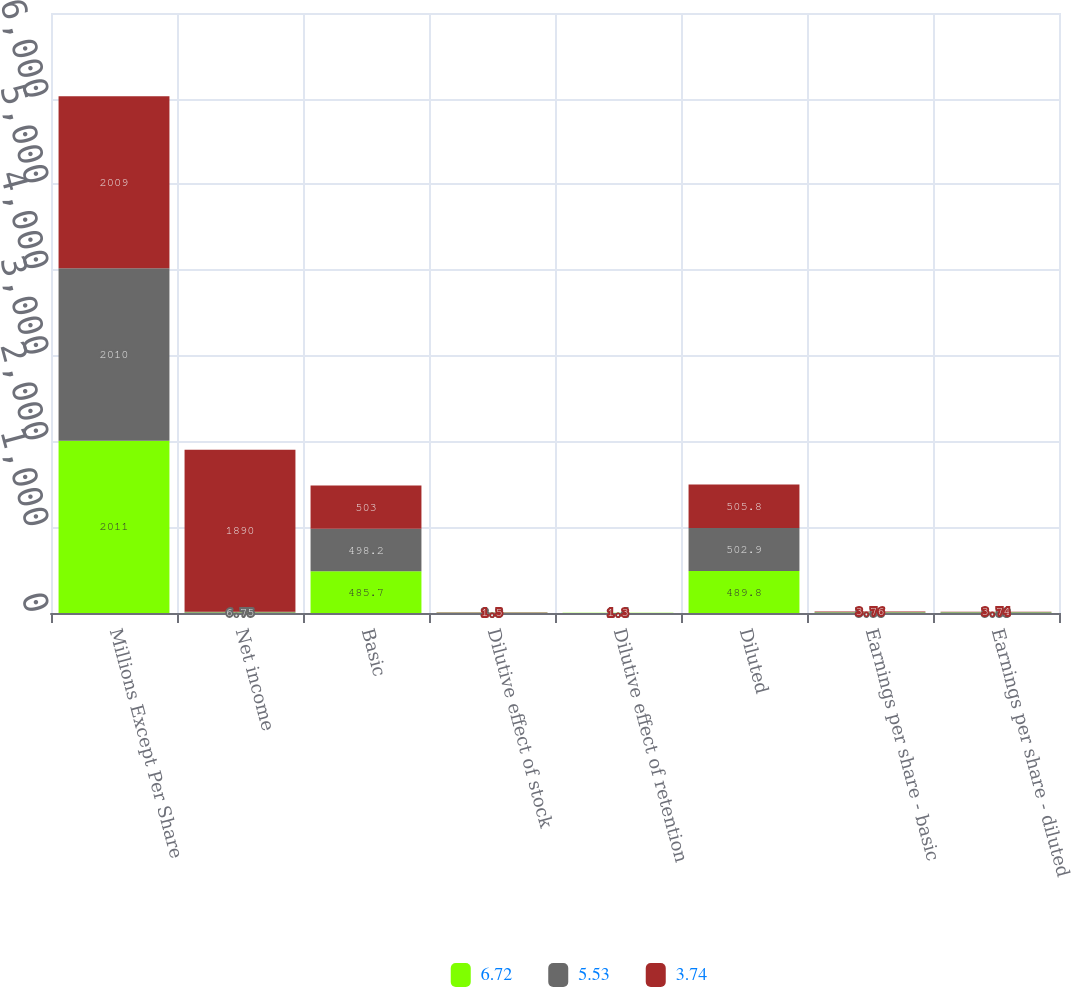Convert chart. <chart><loc_0><loc_0><loc_500><loc_500><stacked_bar_chart><ecel><fcel>Millions Except Per Share<fcel>Net income<fcel>Basic<fcel>Dilutive effect of stock<fcel>Dilutive effect of retention<fcel>Diluted<fcel>Earnings per share - basic<fcel>Earnings per share - diluted<nl><fcel>6.72<fcel>2011<fcel>6.75<fcel>485.7<fcel>2.6<fcel>1.5<fcel>489.8<fcel>6.78<fcel>6.72<nl><fcel>5.53<fcel>2010<fcel>6.75<fcel>498.2<fcel>3.3<fcel>1.4<fcel>502.9<fcel>5.58<fcel>5.53<nl><fcel>3.74<fcel>2009<fcel>1890<fcel>503<fcel>1.5<fcel>1.3<fcel>505.8<fcel>3.76<fcel>3.74<nl></chart> 